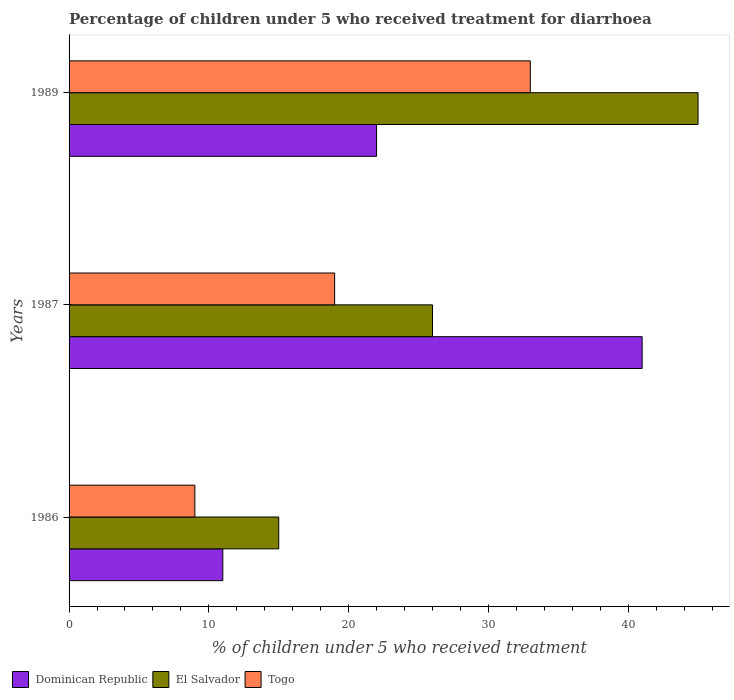How many different coloured bars are there?
Provide a short and direct response. 3. How many groups of bars are there?
Ensure brevity in your answer.  3. Are the number of bars on each tick of the Y-axis equal?
Your answer should be very brief. Yes. In how many cases, is the number of bars for a given year not equal to the number of legend labels?
Ensure brevity in your answer.  0. Across all years, what is the maximum percentage of children who received treatment for diarrhoea  in El Salvador?
Make the answer very short. 45. Across all years, what is the minimum percentage of children who received treatment for diarrhoea  in Togo?
Your response must be concise. 9. In which year was the percentage of children who received treatment for diarrhoea  in Dominican Republic maximum?
Provide a succinct answer. 1987. In which year was the percentage of children who received treatment for diarrhoea  in El Salvador minimum?
Keep it short and to the point. 1986. What is the difference between the percentage of children who received treatment for diarrhoea  in El Salvador in 1986 and that in 1989?
Your answer should be very brief. -30. What is the average percentage of children who received treatment for diarrhoea  in Togo per year?
Your response must be concise. 20.33. In the year 1986, what is the difference between the percentage of children who received treatment for diarrhoea  in Togo and percentage of children who received treatment for diarrhoea  in Dominican Republic?
Your response must be concise. -2. What is the ratio of the percentage of children who received treatment for diarrhoea  in Dominican Republic in 1986 to that in 1989?
Your answer should be very brief. 0.5. Is the percentage of children who received treatment for diarrhoea  in Dominican Republic in 1986 less than that in 1989?
Make the answer very short. Yes. Is the difference between the percentage of children who received treatment for diarrhoea  in Togo in 1986 and 1989 greater than the difference between the percentage of children who received treatment for diarrhoea  in Dominican Republic in 1986 and 1989?
Your response must be concise. No. What is the difference between the highest and the second highest percentage of children who received treatment for diarrhoea  in Togo?
Provide a succinct answer. 14. What is the difference between the highest and the lowest percentage of children who received treatment for diarrhoea  in El Salvador?
Make the answer very short. 30. What does the 2nd bar from the top in 1987 represents?
Your response must be concise. El Salvador. What does the 1st bar from the bottom in 1989 represents?
Offer a terse response. Dominican Republic. Is it the case that in every year, the sum of the percentage of children who received treatment for diarrhoea  in Dominican Republic and percentage of children who received treatment for diarrhoea  in Togo is greater than the percentage of children who received treatment for diarrhoea  in El Salvador?
Offer a terse response. Yes. How many years are there in the graph?
Keep it short and to the point. 3. Are the values on the major ticks of X-axis written in scientific E-notation?
Your answer should be very brief. No. Where does the legend appear in the graph?
Provide a short and direct response. Bottom left. How many legend labels are there?
Your answer should be compact. 3. What is the title of the graph?
Your answer should be very brief. Percentage of children under 5 who received treatment for diarrhoea. Does "Latin America(developing only)" appear as one of the legend labels in the graph?
Your response must be concise. No. What is the label or title of the X-axis?
Your answer should be compact. % of children under 5 who received treatment. What is the label or title of the Y-axis?
Provide a short and direct response. Years. What is the % of children under 5 who received treatment in Dominican Republic in 1989?
Keep it short and to the point. 22. What is the % of children under 5 who received treatment in El Salvador in 1989?
Offer a very short reply. 45. What is the % of children under 5 who received treatment of Togo in 1989?
Provide a short and direct response. 33. Across all years, what is the minimum % of children under 5 who received treatment of El Salvador?
Give a very brief answer. 15. Across all years, what is the minimum % of children under 5 who received treatment in Togo?
Your response must be concise. 9. What is the total % of children under 5 who received treatment in Dominican Republic in the graph?
Provide a short and direct response. 74. What is the total % of children under 5 who received treatment of El Salvador in the graph?
Make the answer very short. 86. What is the difference between the % of children under 5 who received treatment in El Salvador in 1986 and that in 1987?
Offer a terse response. -11. What is the difference between the % of children under 5 who received treatment of Togo in 1986 and that in 1987?
Make the answer very short. -10. What is the difference between the % of children under 5 who received treatment of Dominican Republic in 1986 and that in 1989?
Ensure brevity in your answer.  -11. What is the difference between the % of children under 5 who received treatment of Dominican Republic in 1986 and the % of children under 5 who received treatment of Togo in 1987?
Offer a terse response. -8. What is the difference between the % of children under 5 who received treatment of El Salvador in 1986 and the % of children under 5 who received treatment of Togo in 1987?
Your answer should be compact. -4. What is the difference between the % of children under 5 who received treatment in Dominican Republic in 1986 and the % of children under 5 who received treatment in El Salvador in 1989?
Offer a terse response. -34. What is the difference between the % of children under 5 who received treatment in El Salvador in 1986 and the % of children under 5 who received treatment in Togo in 1989?
Keep it short and to the point. -18. What is the difference between the % of children under 5 who received treatment of El Salvador in 1987 and the % of children under 5 who received treatment of Togo in 1989?
Offer a very short reply. -7. What is the average % of children under 5 who received treatment of Dominican Republic per year?
Your answer should be very brief. 24.67. What is the average % of children under 5 who received treatment of El Salvador per year?
Provide a short and direct response. 28.67. What is the average % of children under 5 who received treatment of Togo per year?
Offer a very short reply. 20.33. In the year 1986, what is the difference between the % of children under 5 who received treatment in Dominican Republic and % of children under 5 who received treatment in Togo?
Offer a terse response. 2. In the year 1986, what is the difference between the % of children under 5 who received treatment in El Salvador and % of children under 5 who received treatment in Togo?
Your answer should be very brief. 6. In the year 1987, what is the difference between the % of children under 5 who received treatment of Dominican Republic and % of children under 5 who received treatment of El Salvador?
Your response must be concise. 15. What is the ratio of the % of children under 5 who received treatment of Dominican Republic in 1986 to that in 1987?
Your answer should be compact. 0.27. What is the ratio of the % of children under 5 who received treatment of El Salvador in 1986 to that in 1987?
Your answer should be compact. 0.58. What is the ratio of the % of children under 5 who received treatment of Togo in 1986 to that in 1987?
Ensure brevity in your answer.  0.47. What is the ratio of the % of children under 5 who received treatment of Togo in 1986 to that in 1989?
Give a very brief answer. 0.27. What is the ratio of the % of children under 5 who received treatment of Dominican Republic in 1987 to that in 1989?
Ensure brevity in your answer.  1.86. What is the ratio of the % of children under 5 who received treatment of El Salvador in 1987 to that in 1989?
Provide a succinct answer. 0.58. What is the ratio of the % of children under 5 who received treatment of Togo in 1987 to that in 1989?
Provide a short and direct response. 0.58. What is the difference between the highest and the second highest % of children under 5 who received treatment of Dominican Republic?
Ensure brevity in your answer.  19. What is the difference between the highest and the second highest % of children under 5 who received treatment of El Salvador?
Your response must be concise. 19. What is the difference between the highest and the lowest % of children under 5 who received treatment in El Salvador?
Your answer should be very brief. 30. What is the difference between the highest and the lowest % of children under 5 who received treatment in Togo?
Keep it short and to the point. 24. 